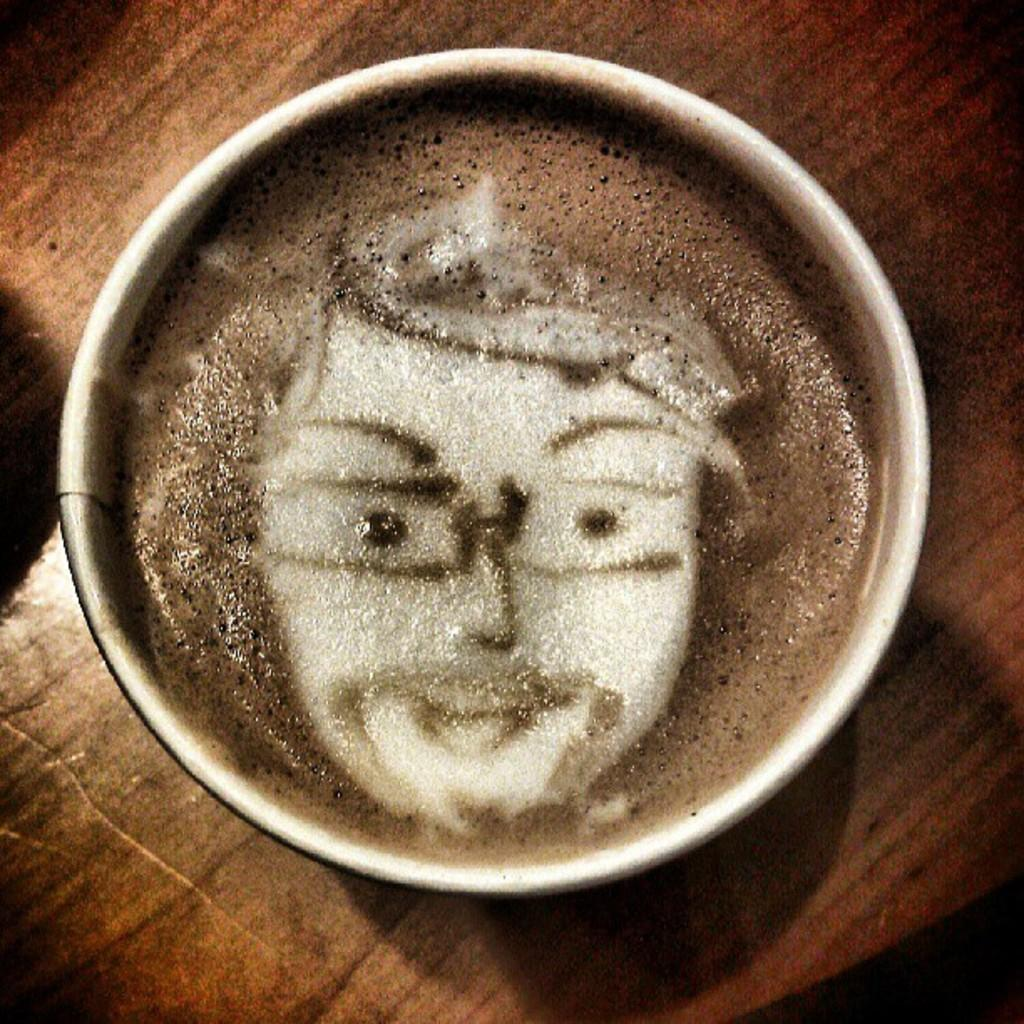What is in the cup that is visible in the image? The cup contains coffee in the image. Where is the cup located? The cup is on a table in the image. What type of egg is sitting on the table next to the cup? There is no egg present in the image; it only features a cup containing coffee on a table. Is there a hat placed on top of the cup in the image? There is no hat present in the image; it only features a cup containing coffee on a table. 